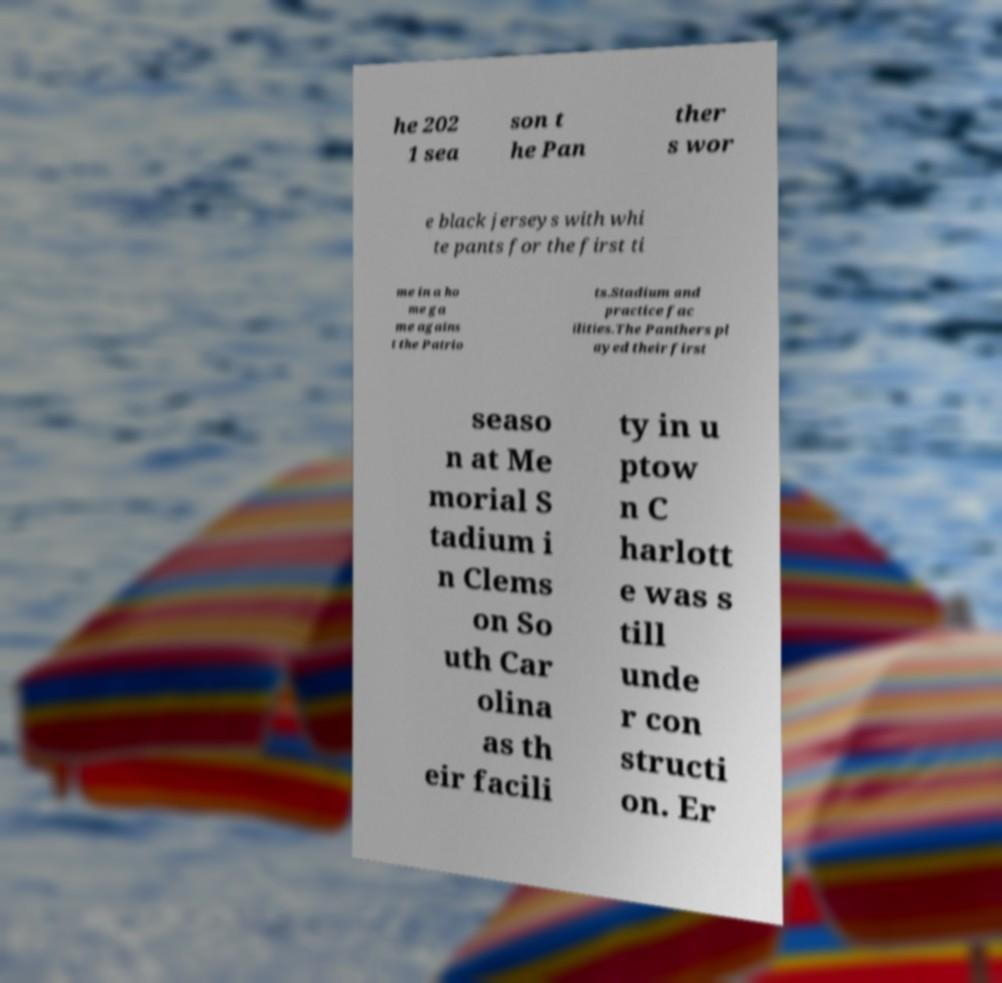Can you accurately transcribe the text from the provided image for me? he 202 1 sea son t he Pan ther s wor e black jerseys with whi te pants for the first ti me in a ho me ga me agains t the Patrio ts.Stadium and practice fac ilities.The Panthers pl ayed their first seaso n at Me morial S tadium i n Clems on So uth Car olina as th eir facili ty in u ptow n C harlott e was s till unde r con structi on. Er 